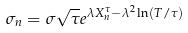<formula> <loc_0><loc_0><loc_500><loc_500>\sigma _ { n } = \sigma \sqrt { \tau } e ^ { \lambda X _ { n } ^ { \tau } - \lambda ^ { 2 } \ln ( T / \tau ) }</formula> 